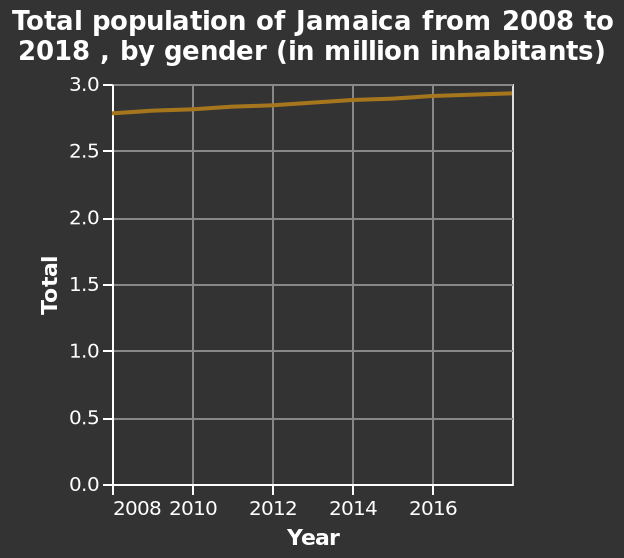<image>
What was the population of the gender in Jamaica 10 years ago?  The population of the gender in Jamaica 10 years ago was 2.8 million. What is the title of the line diagram? The title of the line diagram is "Total population of Jamaica from 2008 to 2018, by gender (in million inhabitants)." 